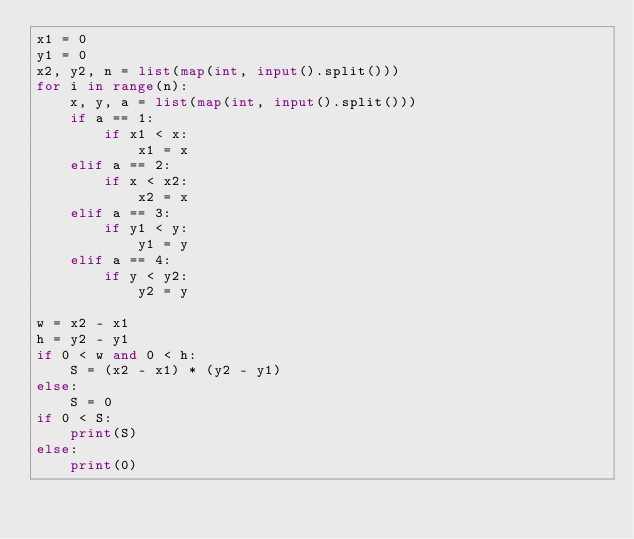Convert code to text. <code><loc_0><loc_0><loc_500><loc_500><_Python_>x1 = 0
y1 = 0
x2, y2, n = list(map(int, input().split()))
for i in range(n):
    x, y, a = list(map(int, input().split()))
    if a == 1:
        if x1 < x:
            x1 = x
    elif a == 2:
        if x < x2:
            x2 = x
    elif a == 3:
        if y1 < y:
            y1 = y
    elif a == 4:
        if y < y2:
            y2 = y

w = x2 - x1
h = y2 - y1
if 0 < w and 0 < h:
    S = (x2 - x1) * (y2 - y1)
else:
    S = 0
if 0 < S:
    print(S)
else:
    print(0)

</code> 